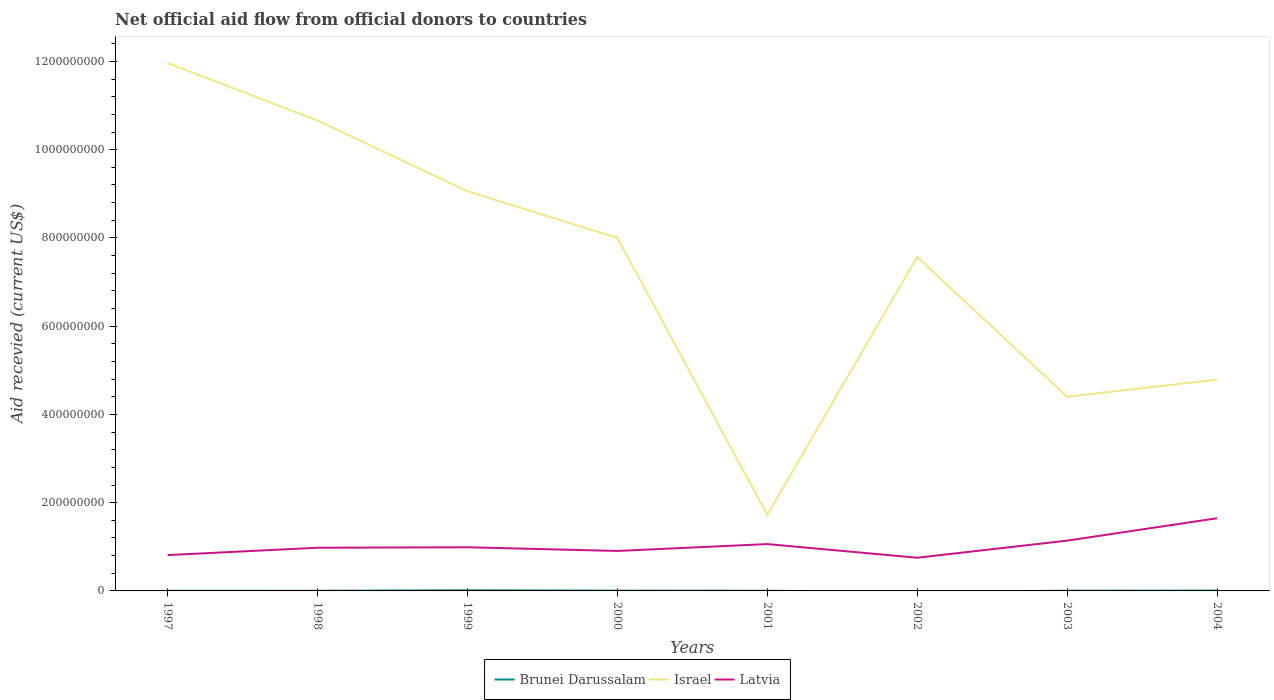What is the total total aid received in Latvia in the graph?
Your answer should be very brief. -1.77e+07. What is the difference between the highest and the second highest total aid received in Latvia?
Keep it short and to the point. 8.95e+07. What is the difference between the highest and the lowest total aid received in Israel?
Your response must be concise. 5. Is the total aid received in Israel strictly greater than the total aid received in Latvia over the years?
Your answer should be compact. No. What is the difference between two consecutive major ticks on the Y-axis?
Your answer should be compact. 2.00e+08. Are the values on the major ticks of Y-axis written in scientific E-notation?
Provide a succinct answer. No. Does the graph contain grids?
Ensure brevity in your answer.  No. How are the legend labels stacked?
Provide a succinct answer. Horizontal. What is the title of the graph?
Provide a succinct answer. Net official aid flow from official donors to countries. Does "Congo (Democratic)" appear as one of the legend labels in the graph?
Ensure brevity in your answer.  No. What is the label or title of the Y-axis?
Offer a terse response. Aid recevied (current US$). What is the Aid recevied (current US$) in Israel in 1997?
Your answer should be very brief. 1.20e+09. What is the Aid recevied (current US$) in Latvia in 1997?
Your answer should be very brief. 8.12e+07. What is the Aid recevied (current US$) of Brunei Darussalam in 1998?
Keep it short and to the point. 3.30e+05. What is the Aid recevied (current US$) in Israel in 1998?
Offer a very short reply. 1.07e+09. What is the Aid recevied (current US$) in Latvia in 1998?
Give a very brief answer. 9.79e+07. What is the Aid recevied (current US$) of Brunei Darussalam in 1999?
Your response must be concise. 1.43e+06. What is the Aid recevied (current US$) of Israel in 1999?
Make the answer very short. 9.06e+08. What is the Aid recevied (current US$) of Latvia in 1999?
Make the answer very short. 9.89e+07. What is the Aid recevied (current US$) in Brunei Darussalam in 2000?
Make the answer very short. 6.30e+05. What is the Aid recevied (current US$) in Israel in 2000?
Keep it short and to the point. 8.00e+08. What is the Aid recevied (current US$) of Latvia in 2000?
Offer a very short reply. 9.06e+07. What is the Aid recevied (current US$) of Brunei Darussalam in 2001?
Your response must be concise. 3.50e+05. What is the Aid recevied (current US$) of Israel in 2001?
Provide a short and direct response. 1.72e+08. What is the Aid recevied (current US$) of Latvia in 2001?
Your answer should be very brief. 1.06e+08. What is the Aid recevied (current US$) in Israel in 2002?
Keep it short and to the point. 7.57e+08. What is the Aid recevied (current US$) of Latvia in 2002?
Provide a succinct answer. 7.52e+07. What is the Aid recevied (current US$) of Israel in 2003?
Provide a short and direct response. 4.40e+08. What is the Aid recevied (current US$) in Latvia in 2003?
Make the answer very short. 1.14e+08. What is the Aid recevied (current US$) of Brunei Darussalam in 2004?
Give a very brief answer. 7.70e+05. What is the Aid recevied (current US$) of Israel in 2004?
Keep it short and to the point. 4.79e+08. What is the Aid recevied (current US$) in Latvia in 2004?
Offer a very short reply. 1.65e+08. Across all years, what is the maximum Aid recevied (current US$) of Brunei Darussalam?
Give a very brief answer. 1.43e+06. Across all years, what is the maximum Aid recevied (current US$) in Israel?
Ensure brevity in your answer.  1.20e+09. Across all years, what is the maximum Aid recevied (current US$) in Latvia?
Your answer should be compact. 1.65e+08. Across all years, what is the minimum Aid recevied (current US$) in Brunei Darussalam?
Provide a succinct answer. 0. Across all years, what is the minimum Aid recevied (current US$) of Israel?
Offer a terse response. 1.72e+08. Across all years, what is the minimum Aid recevied (current US$) in Latvia?
Give a very brief answer. 7.52e+07. What is the total Aid recevied (current US$) in Brunei Darussalam in the graph?
Offer a very short reply. 4.36e+06. What is the total Aid recevied (current US$) in Israel in the graph?
Provide a short and direct response. 5.82e+09. What is the total Aid recevied (current US$) of Latvia in the graph?
Your answer should be compact. 8.29e+08. What is the difference between the Aid recevied (current US$) of Brunei Darussalam in 1997 and that in 1998?
Provide a succinct answer. 5.00e+04. What is the difference between the Aid recevied (current US$) of Israel in 1997 and that in 1998?
Your answer should be very brief. 1.30e+08. What is the difference between the Aid recevied (current US$) of Latvia in 1997 and that in 1998?
Your answer should be very brief. -1.67e+07. What is the difference between the Aid recevied (current US$) of Brunei Darussalam in 1997 and that in 1999?
Your answer should be very brief. -1.05e+06. What is the difference between the Aid recevied (current US$) of Israel in 1997 and that in 1999?
Offer a terse response. 2.91e+08. What is the difference between the Aid recevied (current US$) of Latvia in 1997 and that in 1999?
Your response must be concise. -1.77e+07. What is the difference between the Aid recevied (current US$) in Brunei Darussalam in 1997 and that in 2000?
Offer a terse response. -2.50e+05. What is the difference between the Aid recevied (current US$) of Israel in 1997 and that in 2000?
Give a very brief answer. 3.96e+08. What is the difference between the Aid recevied (current US$) of Latvia in 1997 and that in 2000?
Provide a short and direct response. -9.39e+06. What is the difference between the Aid recevied (current US$) of Israel in 1997 and that in 2001?
Give a very brief answer. 1.02e+09. What is the difference between the Aid recevied (current US$) of Latvia in 1997 and that in 2001?
Your answer should be very brief. -2.49e+07. What is the difference between the Aid recevied (current US$) of Israel in 1997 and that in 2002?
Keep it short and to the point. 4.39e+08. What is the difference between the Aid recevied (current US$) of Israel in 1997 and that in 2003?
Ensure brevity in your answer.  7.56e+08. What is the difference between the Aid recevied (current US$) in Latvia in 1997 and that in 2003?
Keep it short and to the point. -3.27e+07. What is the difference between the Aid recevied (current US$) in Brunei Darussalam in 1997 and that in 2004?
Your answer should be very brief. -3.90e+05. What is the difference between the Aid recevied (current US$) of Israel in 1997 and that in 2004?
Keep it short and to the point. 7.18e+08. What is the difference between the Aid recevied (current US$) in Latvia in 1997 and that in 2004?
Give a very brief answer. -8.35e+07. What is the difference between the Aid recevied (current US$) of Brunei Darussalam in 1998 and that in 1999?
Offer a terse response. -1.10e+06. What is the difference between the Aid recevied (current US$) in Israel in 1998 and that in 1999?
Offer a very short reply. 1.60e+08. What is the difference between the Aid recevied (current US$) of Latvia in 1998 and that in 1999?
Offer a terse response. -1.04e+06. What is the difference between the Aid recevied (current US$) of Brunei Darussalam in 1998 and that in 2000?
Make the answer very short. -3.00e+05. What is the difference between the Aid recevied (current US$) in Israel in 1998 and that in 2000?
Give a very brief answer. 2.66e+08. What is the difference between the Aid recevied (current US$) of Latvia in 1998 and that in 2000?
Provide a short and direct response. 7.30e+06. What is the difference between the Aid recevied (current US$) in Brunei Darussalam in 1998 and that in 2001?
Your response must be concise. -2.00e+04. What is the difference between the Aid recevied (current US$) in Israel in 1998 and that in 2001?
Offer a very short reply. 8.94e+08. What is the difference between the Aid recevied (current US$) in Latvia in 1998 and that in 2001?
Your answer should be very brief. -8.25e+06. What is the difference between the Aid recevied (current US$) of Israel in 1998 and that in 2002?
Offer a terse response. 3.09e+08. What is the difference between the Aid recevied (current US$) in Latvia in 1998 and that in 2002?
Make the answer very short. 2.27e+07. What is the difference between the Aid recevied (current US$) of Israel in 1998 and that in 2003?
Keep it short and to the point. 6.26e+08. What is the difference between the Aid recevied (current US$) of Latvia in 1998 and that in 2003?
Your answer should be compact. -1.60e+07. What is the difference between the Aid recevied (current US$) of Brunei Darussalam in 1998 and that in 2004?
Make the answer very short. -4.40e+05. What is the difference between the Aid recevied (current US$) of Israel in 1998 and that in 2004?
Your answer should be very brief. 5.87e+08. What is the difference between the Aid recevied (current US$) in Latvia in 1998 and that in 2004?
Your response must be concise. -6.68e+07. What is the difference between the Aid recevied (current US$) in Brunei Darussalam in 1999 and that in 2000?
Provide a succinct answer. 8.00e+05. What is the difference between the Aid recevied (current US$) of Israel in 1999 and that in 2000?
Provide a short and direct response. 1.06e+08. What is the difference between the Aid recevied (current US$) of Latvia in 1999 and that in 2000?
Provide a short and direct response. 8.34e+06. What is the difference between the Aid recevied (current US$) in Brunei Darussalam in 1999 and that in 2001?
Give a very brief answer. 1.08e+06. What is the difference between the Aid recevied (current US$) in Israel in 1999 and that in 2001?
Offer a very short reply. 7.33e+08. What is the difference between the Aid recevied (current US$) of Latvia in 1999 and that in 2001?
Keep it short and to the point. -7.21e+06. What is the difference between the Aid recevied (current US$) of Israel in 1999 and that in 2002?
Offer a terse response. 1.49e+08. What is the difference between the Aid recevied (current US$) in Latvia in 1999 and that in 2002?
Provide a succinct answer. 2.37e+07. What is the difference between the Aid recevied (current US$) of Brunei Darussalam in 1999 and that in 2003?
Provide a short and direct response. 9.60e+05. What is the difference between the Aid recevied (current US$) in Israel in 1999 and that in 2003?
Your answer should be compact. 4.66e+08. What is the difference between the Aid recevied (current US$) in Latvia in 1999 and that in 2003?
Offer a terse response. -1.50e+07. What is the difference between the Aid recevied (current US$) of Brunei Darussalam in 1999 and that in 2004?
Your answer should be very brief. 6.60e+05. What is the difference between the Aid recevied (current US$) in Israel in 1999 and that in 2004?
Make the answer very short. 4.27e+08. What is the difference between the Aid recevied (current US$) in Latvia in 1999 and that in 2004?
Keep it short and to the point. -6.58e+07. What is the difference between the Aid recevied (current US$) in Israel in 2000 and that in 2001?
Ensure brevity in your answer.  6.28e+08. What is the difference between the Aid recevied (current US$) of Latvia in 2000 and that in 2001?
Provide a short and direct response. -1.56e+07. What is the difference between the Aid recevied (current US$) of Israel in 2000 and that in 2002?
Keep it short and to the point. 4.31e+07. What is the difference between the Aid recevied (current US$) in Latvia in 2000 and that in 2002?
Offer a terse response. 1.54e+07. What is the difference between the Aid recevied (current US$) of Israel in 2000 and that in 2003?
Your response must be concise. 3.60e+08. What is the difference between the Aid recevied (current US$) of Latvia in 2000 and that in 2003?
Give a very brief answer. -2.34e+07. What is the difference between the Aid recevied (current US$) of Israel in 2000 and that in 2004?
Keep it short and to the point. 3.21e+08. What is the difference between the Aid recevied (current US$) in Latvia in 2000 and that in 2004?
Ensure brevity in your answer.  -7.41e+07. What is the difference between the Aid recevied (current US$) of Israel in 2001 and that in 2002?
Provide a short and direct response. -5.85e+08. What is the difference between the Aid recevied (current US$) in Latvia in 2001 and that in 2002?
Make the answer very short. 3.09e+07. What is the difference between the Aid recevied (current US$) of Israel in 2001 and that in 2003?
Keep it short and to the point. -2.68e+08. What is the difference between the Aid recevied (current US$) of Latvia in 2001 and that in 2003?
Ensure brevity in your answer.  -7.80e+06. What is the difference between the Aid recevied (current US$) of Brunei Darussalam in 2001 and that in 2004?
Keep it short and to the point. -4.20e+05. What is the difference between the Aid recevied (current US$) in Israel in 2001 and that in 2004?
Offer a terse response. -3.06e+08. What is the difference between the Aid recevied (current US$) in Latvia in 2001 and that in 2004?
Provide a short and direct response. -5.86e+07. What is the difference between the Aid recevied (current US$) of Israel in 2002 and that in 2003?
Offer a terse response. 3.17e+08. What is the difference between the Aid recevied (current US$) of Latvia in 2002 and that in 2003?
Ensure brevity in your answer.  -3.87e+07. What is the difference between the Aid recevied (current US$) in Israel in 2002 and that in 2004?
Your answer should be very brief. 2.78e+08. What is the difference between the Aid recevied (current US$) of Latvia in 2002 and that in 2004?
Offer a terse response. -8.95e+07. What is the difference between the Aid recevied (current US$) in Brunei Darussalam in 2003 and that in 2004?
Make the answer very short. -3.00e+05. What is the difference between the Aid recevied (current US$) in Israel in 2003 and that in 2004?
Provide a short and direct response. -3.89e+07. What is the difference between the Aid recevied (current US$) in Latvia in 2003 and that in 2004?
Make the answer very short. -5.08e+07. What is the difference between the Aid recevied (current US$) of Brunei Darussalam in 1997 and the Aid recevied (current US$) of Israel in 1998?
Offer a very short reply. -1.07e+09. What is the difference between the Aid recevied (current US$) in Brunei Darussalam in 1997 and the Aid recevied (current US$) in Latvia in 1998?
Your response must be concise. -9.75e+07. What is the difference between the Aid recevied (current US$) in Israel in 1997 and the Aid recevied (current US$) in Latvia in 1998?
Your response must be concise. 1.10e+09. What is the difference between the Aid recevied (current US$) in Brunei Darussalam in 1997 and the Aid recevied (current US$) in Israel in 1999?
Your answer should be very brief. -9.05e+08. What is the difference between the Aid recevied (current US$) of Brunei Darussalam in 1997 and the Aid recevied (current US$) of Latvia in 1999?
Your response must be concise. -9.86e+07. What is the difference between the Aid recevied (current US$) of Israel in 1997 and the Aid recevied (current US$) of Latvia in 1999?
Provide a short and direct response. 1.10e+09. What is the difference between the Aid recevied (current US$) of Brunei Darussalam in 1997 and the Aid recevied (current US$) of Israel in 2000?
Your response must be concise. -8.00e+08. What is the difference between the Aid recevied (current US$) of Brunei Darussalam in 1997 and the Aid recevied (current US$) of Latvia in 2000?
Give a very brief answer. -9.02e+07. What is the difference between the Aid recevied (current US$) in Israel in 1997 and the Aid recevied (current US$) in Latvia in 2000?
Provide a short and direct response. 1.11e+09. What is the difference between the Aid recevied (current US$) in Brunei Darussalam in 1997 and the Aid recevied (current US$) in Israel in 2001?
Give a very brief answer. -1.72e+08. What is the difference between the Aid recevied (current US$) of Brunei Darussalam in 1997 and the Aid recevied (current US$) of Latvia in 2001?
Keep it short and to the point. -1.06e+08. What is the difference between the Aid recevied (current US$) in Israel in 1997 and the Aid recevied (current US$) in Latvia in 2001?
Provide a short and direct response. 1.09e+09. What is the difference between the Aid recevied (current US$) of Brunei Darussalam in 1997 and the Aid recevied (current US$) of Israel in 2002?
Provide a short and direct response. -7.56e+08. What is the difference between the Aid recevied (current US$) of Brunei Darussalam in 1997 and the Aid recevied (current US$) of Latvia in 2002?
Offer a very short reply. -7.48e+07. What is the difference between the Aid recevied (current US$) in Israel in 1997 and the Aid recevied (current US$) in Latvia in 2002?
Offer a very short reply. 1.12e+09. What is the difference between the Aid recevied (current US$) of Brunei Darussalam in 1997 and the Aid recevied (current US$) of Israel in 2003?
Keep it short and to the point. -4.40e+08. What is the difference between the Aid recevied (current US$) in Brunei Darussalam in 1997 and the Aid recevied (current US$) in Latvia in 2003?
Your response must be concise. -1.14e+08. What is the difference between the Aid recevied (current US$) of Israel in 1997 and the Aid recevied (current US$) of Latvia in 2003?
Give a very brief answer. 1.08e+09. What is the difference between the Aid recevied (current US$) in Brunei Darussalam in 1997 and the Aid recevied (current US$) in Israel in 2004?
Keep it short and to the point. -4.78e+08. What is the difference between the Aid recevied (current US$) of Brunei Darussalam in 1997 and the Aid recevied (current US$) of Latvia in 2004?
Provide a succinct answer. -1.64e+08. What is the difference between the Aid recevied (current US$) of Israel in 1997 and the Aid recevied (current US$) of Latvia in 2004?
Provide a short and direct response. 1.03e+09. What is the difference between the Aid recevied (current US$) of Brunei Darussalam in 1998 and the Aid recevied (current US$) of Israel in 1999?
Provide a short and direct response. -9.05e+08. What is the difference between the Aid recevied (current US$) of Brunei Darussalam in 1998 and the Aid recevied (current US$) of Latvia in 1999?
Offer a very short reply. -9.86e+07. What is the difference between the Aid recevied (current US$) of Israel in 1998 and the Aid recevied (current US$) of Latvia in 1999?
Your response must be concise. 9.67e+08. What is the difference between the Aid recevied (current US$) in Brunei Darussalam in 1998 and the Aid recevied (current US$) in Israel in 2000?
Your answer should be very brief. -8.00e+08. What is the difference between the Aid recevied (current US$) in Brunei Darussalam in 1998 and the Aid recevied (current US$) in Latvia in 2000?
Provide a short and direct response. -9.03e+07. What is the difference between the Aid recevied (current US$) in Israel in 1998 and the Aid recevied (current US$) in Latvia in 2000?
Your answer should be very brief. 9.75e+08. What is the difference between the Aid recevied (current US$) in Brunei Darussalam in 1998 and the Aid recevied (current US$) in Israel in 2001?
Make the answer very short. -1.72e+08. What is the difference between the Aid recevied (current US$) of Brunei Darussalam in 1998 and the Aid recevied (current US$) of Latvia in 2001?
Ensure brevity in your answer.  -1.06e+08. What is the difference between the Aid recevied (current US$) in Israel in 1998 and the Aid recevied (current US$) in Latvia in 2001?
Offer a terse response. 9.60e+08. What is the difference between the Aid recevied (current US$) in Brunei Darussalam in 1998 and the Aid recevied (current US$) in Israel in 2002?
Provide a short and direct response. -7.57e+08. What is the difference between the Aid recevied (current US$) in Brunei Darussalam in 1998 and the Aid recevied (current US$) in Latvia in 2002?
Offer a very short reply. -7.49e+07. What is the difference between the Aid recevied (current US$) of Israel in 1998 and the Aid recevied (current US$) of Latvia in 2002?
Your answer should be very brief. 9.91e+08. What is the difference between the Aid recevied (current US$) in Brunei Darussalam in 1998 and the Aid recevied (current US$) in Israel in 2003?
Offer a terse response. -4.40e+08. What is the difference between the Aid recevied (current US$) in Brunei Darussalam in 1998 and the Aid recevied (current US$) in Latvia in 2003?
Your answer should be very brief. -1.14e+08. What is the difference between the Aid recevied (current US$) of Israel in 1998 and the Aid recevied (current US$) of Latvia in 2003?
Your response must be concise. 9.52e+08. What is the difference between the Aid recevied (current US$) of Brunei Darussalam in 1998 and the Aid recevied (current US$) of Israel in 2004?
Your response must be concise. -4.79e+08. What is the difference between the Aid recevied (current US$) in Brunei Darussalam in 1998 and the Aid recevied (current US$) in Latvia in 2004?
Your answer should be compact. -1.64e+08. What is the difference between the Aid recevied (current US$) in Israel in 1998 and the Aid recevied (current US$) in Latvia in 2004?
Ensure brevity in your answer.  9.01e+08. What is the difference between the Aid recevied (current US$) of Brunei Darussalam in 1999 and the Aid recevied (current US$) of Israel in 2000?
Offer a very short reply. -7.99e+08. What is the difference between the Aid recevied (current US$) of Brunei Darussalam in 1999 and the Aid recevied (current US$) of Latvia in 2000?
Your response must be concise. -8.92e+07. What is the difference between the Aid recevied (current US$) of Israel in 1999 and the Aid recevied (current US$) of Latvia in 2000?
Give a very brief answer. 8.15e+08. What is the difference between the Aid recevied (current US$) in Brunei Darussalam in 1999 and the Aid recevied (current US$) in Israel in 2001?
Offer a terse response. -1.71e+08. What is the difference between the Aid recevied (current US$) of Brunei Darussalam in 1999 and the Aid recevied (current US$) of Latvia in 2001?
Offer a very short reply. -1.05e+08. What is the difference between the Aid recevied (current US$) of Israel in 1999 and the Aid recevied (current US$) of Latvia in 2001?
Ensure brevity in your answer.  8.00e+08. What is the difference between the Aid recevied (current US$) in Brunei Darussalam in 1999 and the Aid recevied (current US$) in Israel in 2002?
Ensure brevity in your answer.  -7.55e+08. What is the difference between the Aid recevied (current US$) of Brunei Darussalam in 1999 and the Aid recevied (current US$) of Latvia in 2002?
Your answer should be compact. -7.38e+07. What is the difference between the Aid recevied (current US$) of Israel in 1999 and the Aid recevied (current US$) of Latvia in 2002?
Provide a succinct answer. 8.31e+08. What is the difference between the Aid recevied (current US$) of Brunei Darussalam in 1999 and the Aid recevied (current US$) of Israel in 2003?
Keep it short and to the point. -4.39e+08. What is the difference between the Aid recevied (current US$) in Brunei Darussalam in 1999 and the Aid recevied (current US$) in Latvia in 2003?
Offer a terse response. -1.13e+08. What is the difference between the Aid recevied (current US$) in Israel in 1999 and the Aid recevied (current US$) in Latvia in 2003?
Keep it short and to the point. 7.92e+08. What is the difference between the Aid recevied (current US$) of Brunei Darussalam in 1999 and the Aid recevied (current US$) of Israel in 2004?
Offer a very short reply. -4.77e+08. What is the difference between the Aid recevied (current US$) in Brunei Darussalam in 1999 and the Aid recevied (current US$) in Latvia in 2004?
Your response must be concise. -1.63e+08. What is the difference between the Aid recevied (current US$) in Israel in 1999 and the Aid recevied (current US$) in Latvia in 2004?
Offer a very short reply. 7.41e+08. What is the difference between the Aid recevied (current US$) in Brunei Darussalam in 2000 and the Aid recevied (current US$) in Israel in 2001?
Provide a succinct answer. -1.72e+08. What is the difference between the Aid recevied (current US$) of Brunei Darussalam in 2000 and the Aid recevied (current US$) of Latvia in 2001?
Ensure brevity in your answer.  -1.06e+08. What is the difference between the Aid recevied (current US$) in Israel in 2000 and the Aid recevied (current US$) in Latvia in 2001?
Offer a terse response. 6.94e+08. What is the difference between the Aid recevied (current US$) of Brunei Darussalam in 2000 and the Aid recevied (current US$) of Israel in 2002?
Give a very brief answer. -7.56e+08. What is the difference between the Aid recevied (current US$) of Brunei Darussalam in 2000 and the Aid recevied (current US$) of Latvia in 2002?
Your response must be concise. -7.46e+07. What is the difference between the Aid recevied (current US$) in Israel in 2000 and the Aid recevied (current US$) in Latvia in 2002?
Your answer should be compact. 7.25e+08. What is the difference between the Aid recevied (current US$) of Brunei Darussalam in 2000 and the Aid recevied (current US$) of Israel in 2003?
Provide a short and direct response. -4.39e+08. What is the difference between the Aid recevied (current US$) of Brunei Darussalam in 2000 and the Aid recevied (current US$) of Latvia in 2003?
Offer a terse response. -1.13e+08. What is the difference between the Aid recevied (current US$) in Israel in 2000 and the Aid recevied (current US$) in Latvia in 2003?
Give a very brief answer. 6.86e+08. What is the difference between the Aid recevied (current US$) of Brunei Darussalam in 2000 and the Aid recevied (current US$) of Israel in 2004?
Offer a very short reply. -4.78e+08. What is the difference between the Aid recevied (current US$) in Brunei Darussalam in 2000 and the Aid recevied (current US$) in Latvia in 2004?
Your answer should be compact. -1.64e+08. What is the difference between the Aid recevied (current US$) in Israel in 2000 and the Aid recevied (current US$) in Latvia in 2004?
Keep it short and to the point. 6.35e+08. What is the difference between the Aid recevied (current US$) of Brunei Darussalam in 2001 and the Aid recevied (current US$) of Israel in 2002?
Give a very brief answer. -7.57e+08. What is the difference between the Aid recevied (current US$) of Brunei Darussalam in 2001 and the Aid recevied (current US$) of Latvia in 2002?
Offer a terse response. -7.48e+07. What is the difference between the Aid recevied (current US$) in Israel in 2001 and the Aid recevied (current US$) in Latvia in 2002?
Provide a succinct answer. 9.72e+07. What is the difference between the Aid recevied (current US$) of Brunei Darussalam in 2001 and the Aid recevied (current US$) of Israel in 2003?
Give a very brief answer. -4.40e+08. What is the difference between the Aid recevied (current US$) of Brunei Darussalam in 2001 and the Aid recevied (current US$) of Latvia in 2003?
Offer a very short reply. -1.14e+08. What is the difference between the Aid recevied (current US$) of Israel in 2001 and the Aid recevied (current US$) of Latvia in 2003?
Offer a very short reply. 5.84e+07. What is the difference between the Aid recevied (current US$) in Brunei Darussalam in 2001 and the Aid recevied (current US$) in Israel in 2004?
Make the answer very short. -4.78e+08. What is the difference between the Aid recevied (current US$) of Brunei Darussalam in 2001 and the Aid recevied (current US$) of Latvia in 2004?
Offer a very short reply. -1.64e+08. What is the difference between the Aid recevied (current US$) of Israel in 2001 and the Aid recevied (current US$) of Latvia in 2004?
Your answer should be compact. 7.63e+06. What is the difference between the Aid recevied (current US$) in Israel in 2002 and the Aid recevied (current US$) in Latvia in 2003?
Keep it short and to the point. 6.43e+08. What is the difference between the Aid recevied (current US$) in Israel in 2002 and the Aid recevied (current US$) in Latvia in 2004?
Ensure brevity in your answer.  5.92e+08. What is the difference between the Aid recevied (current US$) in Brunei Darussalam in 2003 and the Aid recevied (current US$) in Israel in 2004?
Your answer should be very brief. -4.78e+08. What is the difference between the Aid recevied (current US$) of Brunei Darussalam in 2003 and the Aid recevied (current US$) of Latvia in 2004?
Your answer should be compact. -1.64e+08. What is the difference between the Aid recevied (current US$) of Israel in 2003 and the Aid recevied (current US$) of Latvia in 2004?
Offer a terse response. 2.75e+08. What is the average Aid recevied (current US$) of Brunei Darussalam per year?
Make the answer very short. 5.45e+05. What is the average Aid recevied (current US$) in Israel per year?
Ensure brevity in your answer.  7.27e+08. What is the average Aid recevied (current US$) in Latvia per year?
Provide a succinct answer. 1.04e+08. In the year 1997, what is the difference between the Aid recevied (current US$) of Brunei Darussalam and Aid recevied (current US$) of Israel?
Ensure brevity in your answer.  -1.20e+09. In the year 1997, what is the difference between the Aid recevied (current US$) of Brunei Darussalam and Aid recevied (current US$) of Latvia?
Keep it short and to the point. -8.08e+07. In the year 1997, what is the difference between the Aid recevied (current US$) in Israel and Aid recevied (current US$) in Latvia?
Provide a succinct answer. 1.12e+09. In the year 1998, what is the difference between the Aid recevied (current US$) in Brunei Darussalam and Aid recevied (current US$) in Israel?
Ensure brevity in your answer.  -1.07e+09. In the year 1998, what is the difference between the Aid recevied (current US$) of Brunei Darussalam and Aid recevied (current US$) of Latvia?
Your response must be concise. -9.76e+07. In the year 1998, what is the difference between the Aid recevied (current US$) in Israel and Aid recevied (current US$) in Latvia?
Make the answer very short. 9.68e+08. In the year 1999, what is the difference between the Aid recevied (current US$) of Brunei Darussalam and Aid recevied (current US$) of Israel?
Your response must be concise. -9.04e+08. In the year 1999, what is the difference between the Aid recevied (current US$) of Brunei Darussalam and Aid recevied (current US$) of Latvia?
Make the answer very short. -9.75e+07. In the year 1999, what is the difference between the Aid recevied (current US$) in Israel and Aid recevied (current US$) in Latvia?
Provide a short and direct response. 8.07e+08. In the year 2000, what is the difference between the Aid recevied (current US$) of Brunei Darussalam and Aid recevied (current US$) of Israel?
Make the answer very short. -7.99e+08. In the year 2000, what is the difference between the Aid recevied (current US$) in Brunei Darussalam and Aid recevied (current US$) in Latvia?
Make the answer very short. -9.00e+07. In the year 2000, what is the difference between the Aid recevied (current US$) of Israel and Aid recevied (current US$) of Latvia?
Give a very brief answer. 7.09e+08. In the year 2001, what is the difference between the Aid recevied (current US$) in Brunei Darussalam and Aid recevied (current US$) in Israel?
Give a very brief answer. -1.72e+08. In the year 2001, what is the difference between the Aid recevied (current US$) in Brunei Darussalam and Aid recevied (current US$) in Latvia?
Give a very brief answer. -1.06e+08. In the year 2001, what is the difference between the Aid recevied (current US$) in Israel and Aid recevied (current US$) in Latvia?
Provide a succinct answer. 6.62e+07. In the year 2002, what is the difference between the Aid recevied (current US$) in Israel and Aid recevied (current US$) in Latvia?
Your response must be concise. 6.82e+08. In the year 2003, what is the difference between the Aid recevied (current US$) in Brunei Darussalam and Aid recevied (current US$) in Israel?
Keep it short and to the point. -4.40e+08. In the year 2003, what is the difference between the Aid recevied (current US$) of Brunei Darussalam and Aid recevied (current US$) of Latvia?
Offer a very short reply. -1.13e+08. In the year 2003, what is the difference between the Aid recevied (current US$) in Israel and Aid recevied (current US$) in Latvia?
Your answer should be compact. 3.26e+08. In the year 2004, what is the difference between the Aid recevied (current US$) in Brunei Darussalam and Aid recevied (current US$) in Israel?
Offer a very short reply. -4.78e+08. In the year 2004, what is the difference between the Aid recevied (current US$) of Brunei Darussalam and Aid recevied (current US$) of Latvia?
Offer a terse response. -1.64e+08. In the year 2004, what is the difference between the Aid recevied (current US$) in Israel and Aid recevied (current US$) in Latvia?
Your answer should be compact. 3.14e+08. What is the ratio of the Aid recevied (current US$) in Brunei Darussalam in 1997 to that in 1998?
Your answer should be very brief. 1.15. What is the ratio of the Aid recevied (current US$) in Israel in 1997 to that in 1998?
Provide a short and direct response. 1.12. What is the ratio of the Aid recevied (current US$) of Latvia in 1997 to that in 1998?
Offer a terse response. 0.83. What is the ratio of the Aid recevied (current US$) of Brunei Darussalam in 1997 to that in 1999?
Make the answer very short. 0.27. What is the ratio of the Aid recevied (current US$) in Israel in 1997 to that in 1999?
Make the answer very short. 1.32. What is the ratio of the Aid recevied (current US$) in Latvia in 1997 to that in 1999?
Provide a succinct answer. 0.82. What is the ratio of the Aid recevied (current US$) of Brunei Darussalam in 1997 to that in 2000?
Your answer should be compact. 0.6. What is the ratio of the Aid recevied (current US$) of Israel in 1997 to that in 2000?
Give a very brief answer. 1.5. What is the ratio of the Aid recevied (current US$) in Latvia in 1997 to that in 2000?
Make the answer very short. 0.9. What is the ratio of the Aid recevied (current US$) in Brunei Darussalam in 1997 to that in 2001?
Ensure brevity in your answer.  1.09. What is the ratio of the Aid recevied (current US$) of Israel in 1997 to that in 2001?
Ensure brevity in your answer.  6.94. What is the ratio of the Aid recevied (current US$) in Latvia in 1997 to that in 2001?
Offer a very short reply. 0.77. What is the ratio of the Aid recevied (current US$) of Israel in 1997 to that in 2002?
Give a very brief answer. 1.58. What is the ratio of the Aid recevied (current US$) of Latvia in 1997 to that in 2002?
Your answer should be very brief. 1.08. What is the ratio of the Aid recevied (current US$) of Brunei Darussalam in 1997 to that in 2003?
Your answer should be very brief. 0.81. What is the ratio of the Aid recevied (current US$) of Israel in 1997 to that in 2003?
Your response must be concise. 2.72. What is the ratio of the Aid recevied (current US$) in Latvia in 1997 to that in 2003?
Keep it short and to the point. 0.71. What is the ratio of the Aid recevied (current US$) of Brunei Darussalam in 1997 to that in 2004?
Provide a short and direct response. 0.49. What is the ratio of the Aid recevied (current US$) of Israel in 1997 to that in 2004?
Make the answer very short. 2.5. What is the ratio of the Aid recevied (current US$) of Latvia in 1997 to that in 2004?
Your answer should be very brief. 0.49. What is the ratio of the Aid recevied (current US$) in Brunei Darussalam in 1998 to that in 1999?
Ensure brevity in your answer.  0.23. What is the ratio of the Aid recevied (current US$) in Israel in 1998 to that in 1999?
Your answer should be very brief. 1.18. What is the ratio of the Aid recevied (current US$) in Brunei Darussalam in 1998 to that in 2000?
Provide a succinct answer. 0.52. What is the ratio of the Aid recevied (current US$) in Israel in 1998 to that in 2000?
Make the answer very short. 1.33. What is the ratio of the Aid recevied (current US$) in Latvia in 1998 to that in 2000?
Offer a very short reply. 1.08. What is the ratio of the Aid recevied (current US$) in Brunei Darussalam in 1998 to that in 2001?
Provide a succinct answer. 0.94. What is the ratio of the Aid recevied (current US$) in Israel in 1998 to that in 2001?
Your answer should be very brief. 6.19. What is the ratio of the Aid recevied (current US$) of Latvia in 1998 to that in 2001?
Your answer should be very brief. 0.92. What is the ratio of the Aid recevied (current US$) of Israel in 1998 to that in 2002?
Ensure brevity in your answer.  1.41. What is the ratio of the Aid recevied (current US$) of Latvia in 1998 to that in 2002?
Offer a very short reply. 1.3. What is the ratio of the Aid recevied (current US$) in Brunei Darussalam in 1998 to that in 2003?
Offer a very short reply. 0.7. What is the ratio of the Aid recevied (current US$) in Israel in 1998 to that in 2003?
Your answer should be compact. 2.42. What is the ratio of the Aid recevied (current US$) of Latvia in 1998 to that in 2003?
Your response must be concise. 0.86. What is the ratio of the Aid recevied (current US$) of Brunei Darussalam in 1998 to that in 2004?
Your answer should be compact. 0.43. What is the ratio of the Aid recevied (current US$) in Israel in 1998 to that in 2004?
Your answer should be very brief. 2.23. What is the ratio of the Aid recevied (current US$) of Latvia in 1998 to that in 2004?
Offer a terse response. 0.59. What is the ratio of the Aid recevied (current US$) of Brunei Darussalam in 1999 to that in 2000?
Give a very brief answer. 2.27. What is the ratio of the Aid recevied (current US$) in Israel in 1999 to that in 2000?
Provide a succinct answer. 1.13. What is the ratio of the Aid recevied (current US$) in Latvia in 1999 to that in 2000?
Offer a terse response. 1.09. What is the ratio of the Aid recevied (current US$) in Brunei Darussalam in 1999 to that in 2001?
Your answer should be compact. 4.09. What is the ratio of the Aid recevied (current US$) of Israel in 1999 to that in 2001?
Ensure brevity in your answer.  5.26. What is the ratio of the Aid recevied (current US$) of Latvia in 1999 to that in 2001?
Provide a succinct answer. 0.93. What is the ratio of the Aid recevied (current US$) of Israel in 1999 to that in 2002?
Your answer should be very brief. 1.2. What is the ratio of the Aid recevied (current US$) in Latvia in 1999 to that in 2002?
Keep it short and to the point. 1.32. What is the ratio of the Aid recevied (current US$) of Brunei Darussalam in 1999 to that in 2003?
Provide a short and direct response. 3.04. What is the ratio of the Aid recevied (current US$) of Israel in 1999 to that in 2003?
Offer a very short reply. 2.06. What is the ratio of the Aid recevied (current US$) of Latvia in 1999 to that in 2003?
Your answer should be compact. 0.87. What is the ratio of the Aid recevied (current US$) of Brunei Darussalam in 1999 to that in 2004?
Provide a short and direct response. 1.86. What is the ratio of the Aid recevied (current US$) in Israel in 1999 to that in 2004?
Your response must be concise. 1.89. What is the ratio of the Aid recevied (current US$) of Latvia in 1999 to that in 2004?
Your response must be concise. 0.6. What is the ratio of the Aid recevied (current US$) in Brunei Darussalam in 2000 to that in 2001?
Your response must be concise. 1.8. What is the ratio of the Aid recevied (current US$) in Israel in 2000 to that in 2001?
Offer a terse response. 4.64. What is the ratio of the Aid recevied (current US$) in Latvia in 2000 to that in 2001?
Make the answer very short. 0.85. What is the ratio of the Aid recevied (current US$) of Israel in 2000 to that in 2002?
Make the answer very short. 1.06. What is the ratio of the Aid recevied (current US$) of Latvia in 2000 to that in 2002?
Give a very brief answer. 1.2. What is the ratio of the Aid recevied (current US$) of Brunei Darussalam in 2000 to that in 2003?
Ensure brevity in your answer.  1.34. What is the ratio of the Aid recevied (current US$) in Israel in 2000 to that in 2003?
Offer a very short reply. 1.82. What is the ratio of the Aid recevied (current US$) of Latvia in 2000 to that in 2003?
Ensure brevity in your answer.  0.8. What is the ratio of the Aid recevied (current US$) of Brunei Darussalam in 2000 to that in 2004?
Your answer should be very brief. 0.82. What is the ratio of the Aid recevied (current US$) of Israel in 2000 to that in 2004?
Provide a short and direct response. 1.67. What is the ratio of the Aid recevied (current US$) of Latvia in 2000 to that in 2004?
Your answer should be compact. 0.55. What is the ratio of the Aid recevied (current US$) of Israel in 2001 to that in 2002?
Your answer should be compact. 0.23. What is the ratio of the Aid recevied (current US$) in Latvia in 2001 to that in 2002?
Keep it short and to the point. 1.41. What is the ratio of the Aid recevied (current US$) in Brunei Darussalam in 2001 to that in 2003?
Provide a short and direct response. 0.74. What is the ratio of the Aid recevied (current US$) of Israel in 2001 to that in 2003?
Your response must be concise. 0.39. What is the ratio of the Aid recevied (current US$) of Latvia in 2001 to that in 2003?
Make the answer very short. 0.93. What is the ratio of the Aid recevied (current US$) in Brunei Darussalam in 2001 to that in 2004?
Provide a succinct answer. 0.45. What is the ratio of the Aid recevied (current US$) in Israel in 2001 to that in 2004?
Keep it short and to the point. 0.36. What is the ratio of the Aid recevied (current US$) in Latvia in 2001 to that in 2004?
Ensure brevity in your answer.  0.64. What is the ratio of the Aid recevied (current US$) of Israel in 2002 to that in 2003?
Offer a terse response. 1.72. What is the ratio of the Aid recevied (current US$) of Latvia in 2002 to that in 2003?
Your answer should be compact. 0.66. What is the ratio of the Aid recevied (current US$) of Israel in 2002 to that in 2004?
Give a very brief answer. 1.58. What is the ratio of the Aid recevied (current US$) in Latvia in 2002 to that in 2004?
Ensure brevity in your answer.  0.46. What is the ratio of the Aid recevied (current US$) in Brunei Darussalam in 2003 to that in 2004?
Your response must be concise. 0.61. What is the ratio of the Aid recevied (current US$) of Israel in 2003 to that in 2004?
Provide a short and direct response. 0.92. What is the ratio of the Aid recevied (current US$) in Latvia in 2003 to that in 2004?
Provide a short and direct response. 0.69. What is the difference between the highest and the second highest Aid recevied (current US$) of Brunei Darussalam?
Give a very brief answer. 6.60e+05. What is the difference between the highest and the second highest Aid recevied (current US$) in Israel?
Your response must be concise. 1.30e+08. What is the difference between the highest and the second highest Aid recevied (current US$) of Latvia?
Make the answer very short. 5.08e+07. What is the difference between the highest and the lowest Aid recevied (current US$) of Brunei Darussalam?
Provide a succinct answer. 1.43e+06. What is the difference between the highest and the lowest Aid recevied (current US$) in Israel?
Your response must be concise. 1.02e+09. What is the difference between the highest and the lowest Aid recevied (current US$) of Latvia?
Make the answer very short. 8.95e+07. 